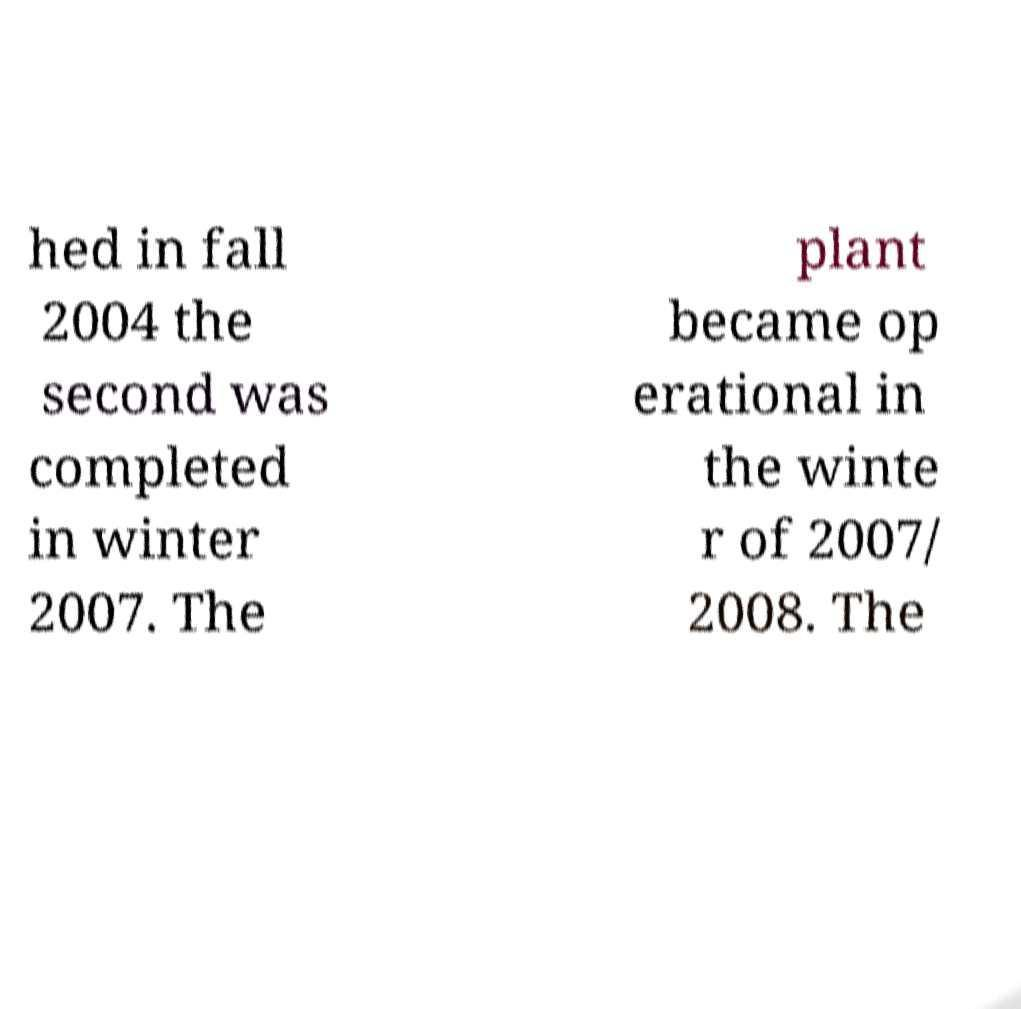Please identify and transcribe the text found in this image. hed in fall 2004 the second was completed in winter 2007. The plant became op erational in the winte r of 2007/ 2008. The 